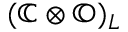Convert formula to latex. <formula><loc_0><loc_0><loc_500><loc_500>( \mathbb { C } \otimes \mathbb { O } ) _ { L }</formula> 